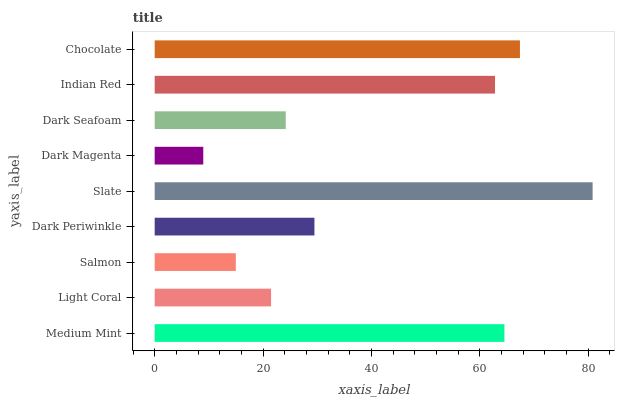Is Dark Magenta the minimum?
Answer yes or no. Yes. Is Slate the maximum?
Answer yes or no. Yes. Is Light Coral the minimum?
Answer yes or no. No. Is Light Coral the maximum?
Answer yes or no. No. Is Medium Mint greater than Light Coral?
Answer yes or no. Yes. Is Light Coral less than Medium Mint?
Answer yes or no. Yes. Is Light Coral greater than Medium Mint?
Answer yes or no. No. Is Medium Mint less than Light Coral?
Answer yes or no. No. Is Dark Periwinkle the high median?
Answer yes or no. Yes. Is Dark Periwinkle the low median?
Answer yes or no. Yes. Is Dark Magenta the high median?
Answer yes or no. No. Is Dark Magenta the low median?
Answer yes or no. No. 